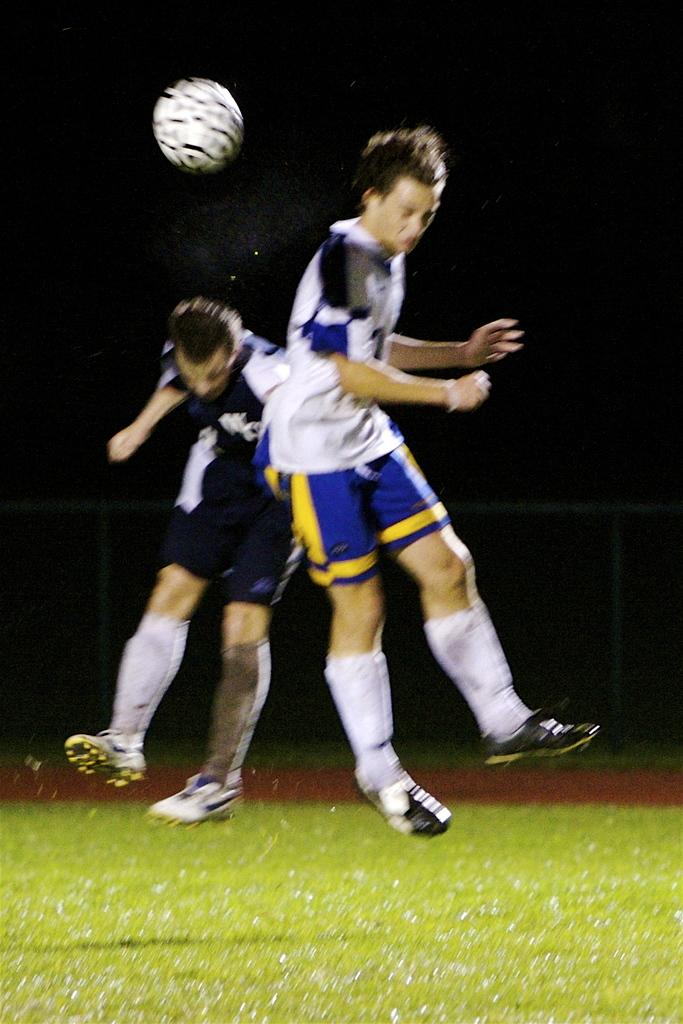How many people are in the image? There are two people in the image. What are the people doing in the image? The people are jumping in the air. What type of surface is visible in the image? There is grass visible in the image. What object can be seen in the image besides the people? There is a ball in the image. Can you see any cobwebs in the image? There are no cobwebs present in the image. What is the temper of the people in the image? The image does not provide information about the temper of the people; it only shows them jumping in the air. 